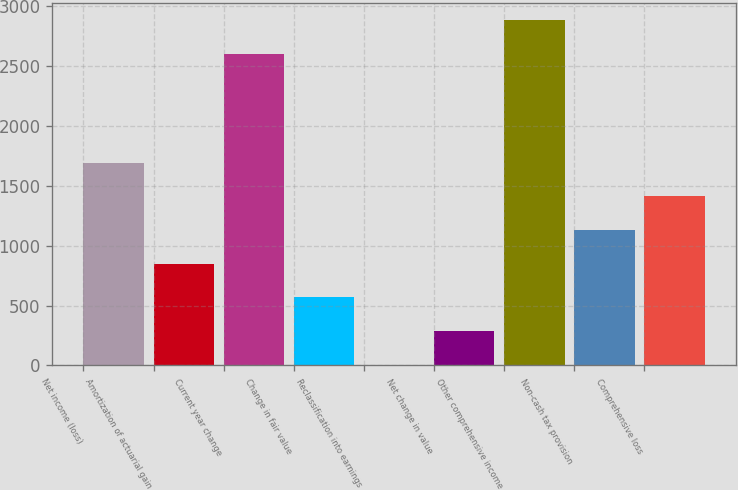<chart> <loc_0><loc_0><loc_500><loc_500><bar_chart><fcel>Net income (loss)<fcel>Amortization of actuarial gain<fcel>Current year change<fcel>Change in fair value<fcel>Reclassification into earnings<fcel>Net change in value<fcel>Other comprehensive income<fcel>Non-cash tax provision<fcel>Comprehensive loss<nl><fcel>1694.2<fcel>849.1<fcel>2602<fcel>567.4<fcel>4<fcel>285.7<fcel>2883.7<fcel>1130.8<fcel>1412.5<nl></chart> 